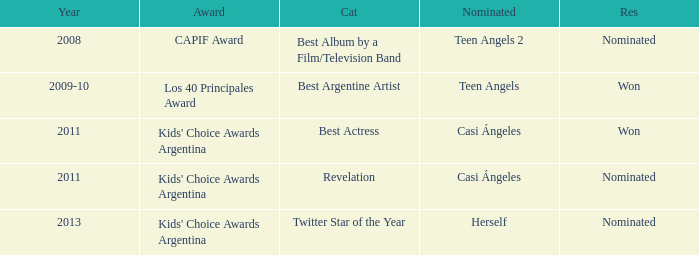For what award was there a nomination for Best Actress? Kids' Choice Awards Argentina. 